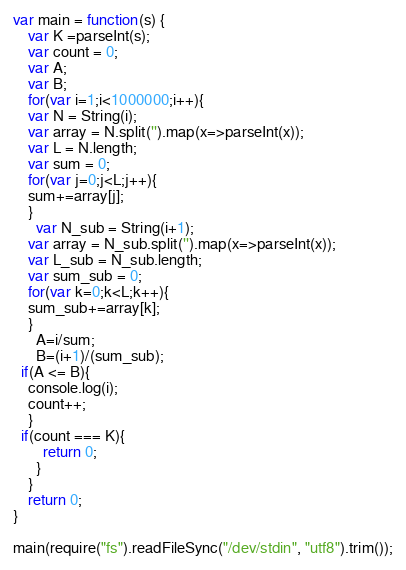Convert code to text. <code><loc_0><loc_0><loc_500><loc_500><_JavaScript_>var main = function(s) {
	var K =parseInt(s);
  	var count = 0;
  	var A;
  	var B;
  	for(var i=1;i<1000000;i++){
  	var N = String(i);
  	var array = N.split('').map(x=>parseInt(x));
  	var L = N.length;
  	var sum = 0;
  	for(var j=0;j<L;j++){
  	sum+=array[j];
    }
      var N_sub = String(i+1);
  	var array = N_sub.split('').map(x=>parseInt(x));
  	var L_sub = N_sub.length;
  	var sum_sub = 0;
  	for(var k=0;k<L;k++){
  	sum_sub+=array[k];
    }
      A=i/sum;
      B=(i+1)/(sum_sub);
  if(A <= B){
    console.log(i);
    count++;
  	}
  if(count === K){
        return 0;
      }
    }
    return 0; 
}

main(require("fs").readFileSync("/dev/stdin", "utf8").trim());
</code> 